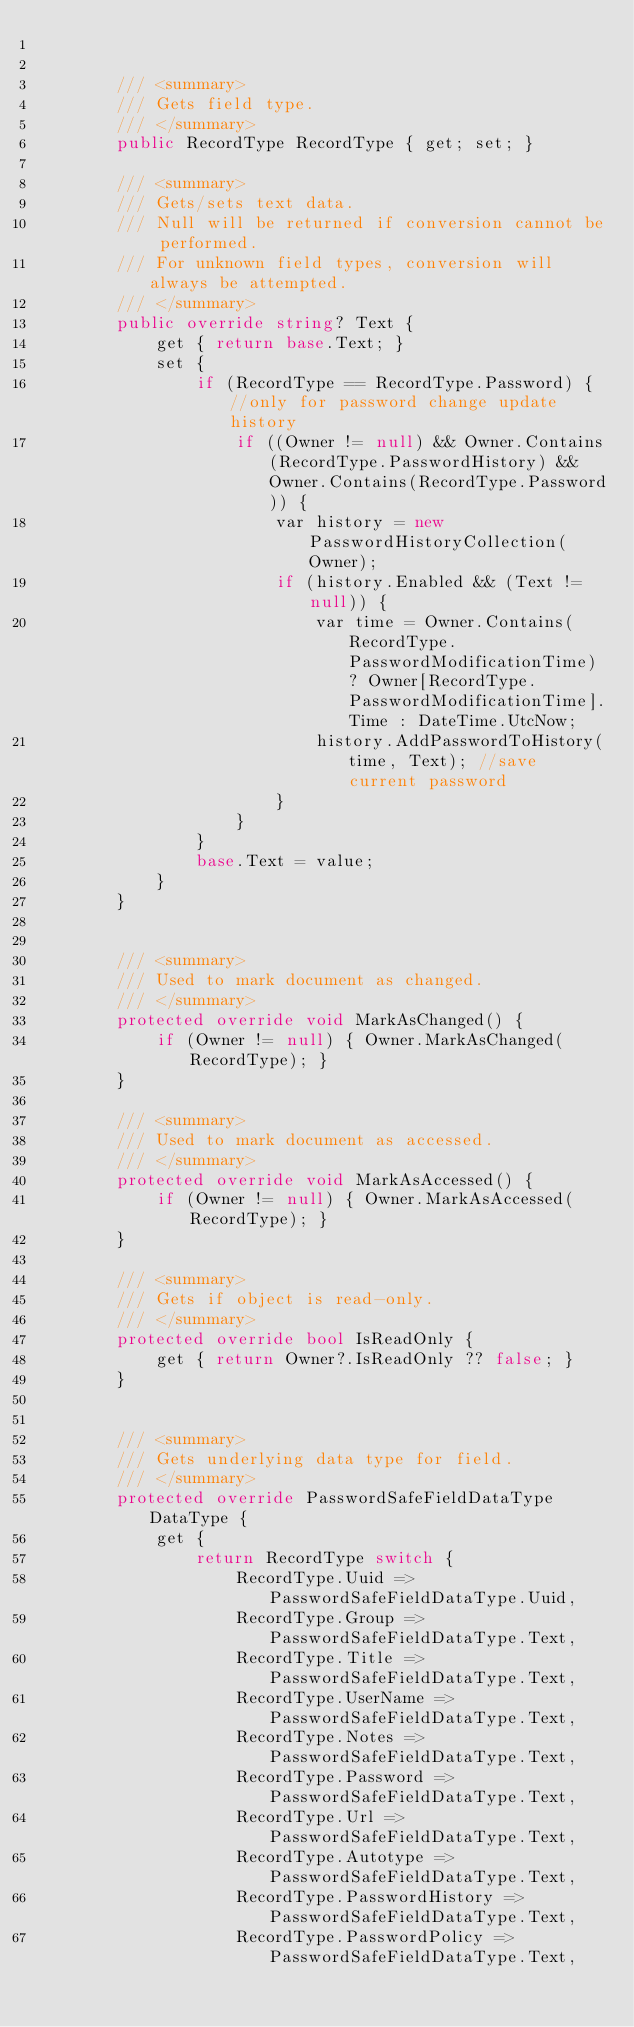Convert code to text. <code><loc_0><loc_0><loc_500><loc_500><_C#_>

        /// <summary>
        /// Gets field type.
        /// </summary>
        public RecordType RecordType { get; set; }

        /// <summary>
        /// Gets/sets text data.
        /// Null will be returned if conversion cannot be performed.
        /// For unknown field types, conversion will always be attempted.
        /// </summary>
        public override string? Text {
            get { return base.Text; }
            set {
                if (RecordType == RecordType.Password) { //only for password change update history
                    if ((Owner != null) && Owner.Contains(RecordType.PasswordHistory) && Owner.Contains(RecordType.Password)) {
                        var history = new PasswordHistoryCollection(Owner);
                        if (history.Enabled && (Text != null)) {
                            var time = Owner.Contains(RecordType.PasswordModificationTime) ? Owner[RecordType.PasswordModificationTime].Time : DateTime.UtcNow;
                            history.AddPasswordToHistory(time, Text); //save current password
                        }
                    }
                }
                base.Text = value;
            }
        }


        /// <summary>
        /// Used to mark document as changed.
        /// </summary>
        protected override void MarkAsChanged() {
            if (Owner != null) { Owner.MarkAsChanged(RecordType); }
        }

        /// <summary>
        /// Used to mark document as accessed.
        /// </summary>
        protected override void MarkAsAccessed() {
            if (Owner != null) { Owner.MarkAsAccessed(RecordType); }
        }

        /// <summary>
        /// Gets if object is read-only.
        /// </summary>
        protected override bool IsReadOnly {
            get { return Owner?.IsReadOnly ?? false; }
        }


        /// <summary>
        /// Gets underlying data type for field.
        /// </summary>
        protected override PasswordSafeFieldDataType DataType {
            get {
                return RecordType switch {
                    RecordType.Uuid => PasswordSafeFieldDataType.Uuid,
                    RecordType.Group => PasswordSafeFieldDataType.Text,
                    RecordType.Title => PasswordSafeFieldDataType.Text,
                    RecordType.UserName => PasswordSafeFieldDataType.Text,
                    RecordType.Notes => PasswordSafeFieldDataType.Text,
                    RecordType.Password => PasswordSafeFieldDataType.Text,
                    RecordType.Url => PasswordSafeFieldDataType.Text,
                    RecordType.Autotype => PasswordSafeFieldDataType.Text,
                    RecordType.PasswordHistory => PasswordSafeFieldDataType.Text,
                    RecordType.PasswordPolicy => PasswordSafeFieldDataType.Text,</code> 